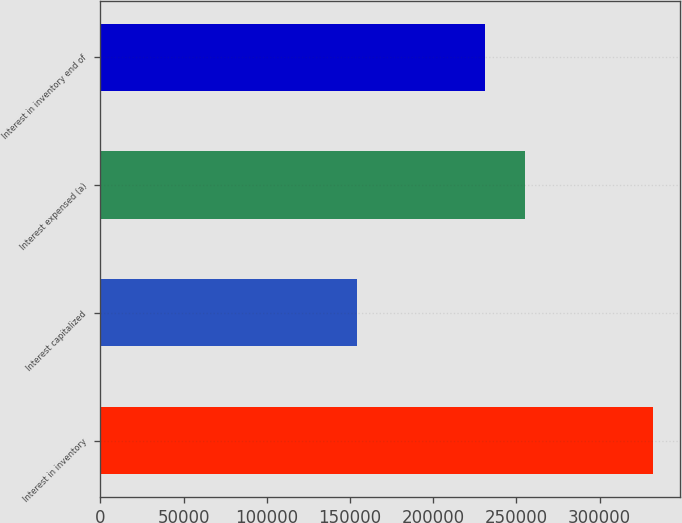Convert chart to OTSL. <chart><loc_0><loc_0><loc_500><loc_500><bar_chart><fcel>Interest in inventory<fcel>Interest capitalized<fcel>Interest expensed (a)<fcel>Interest in inventory end of<nl><fcel>331880<fcel>154107<fcel>255065<fcel>230922<nl></chart> 